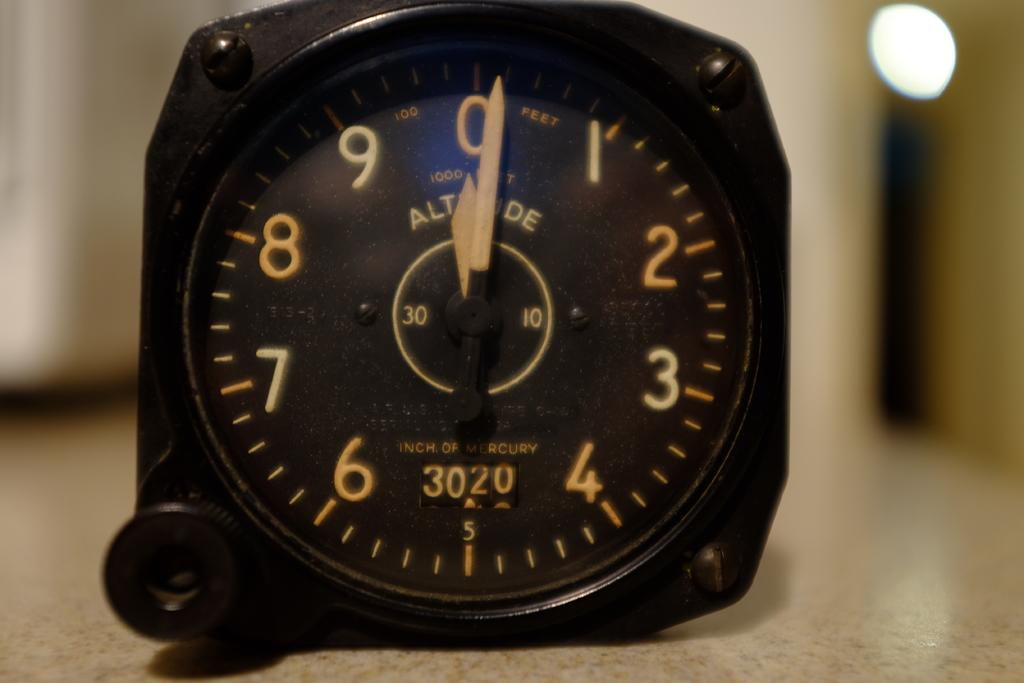What is the four digit number?
Make the answer very short. 3020. What time is it?
Offer a very short reply. 12:01. 